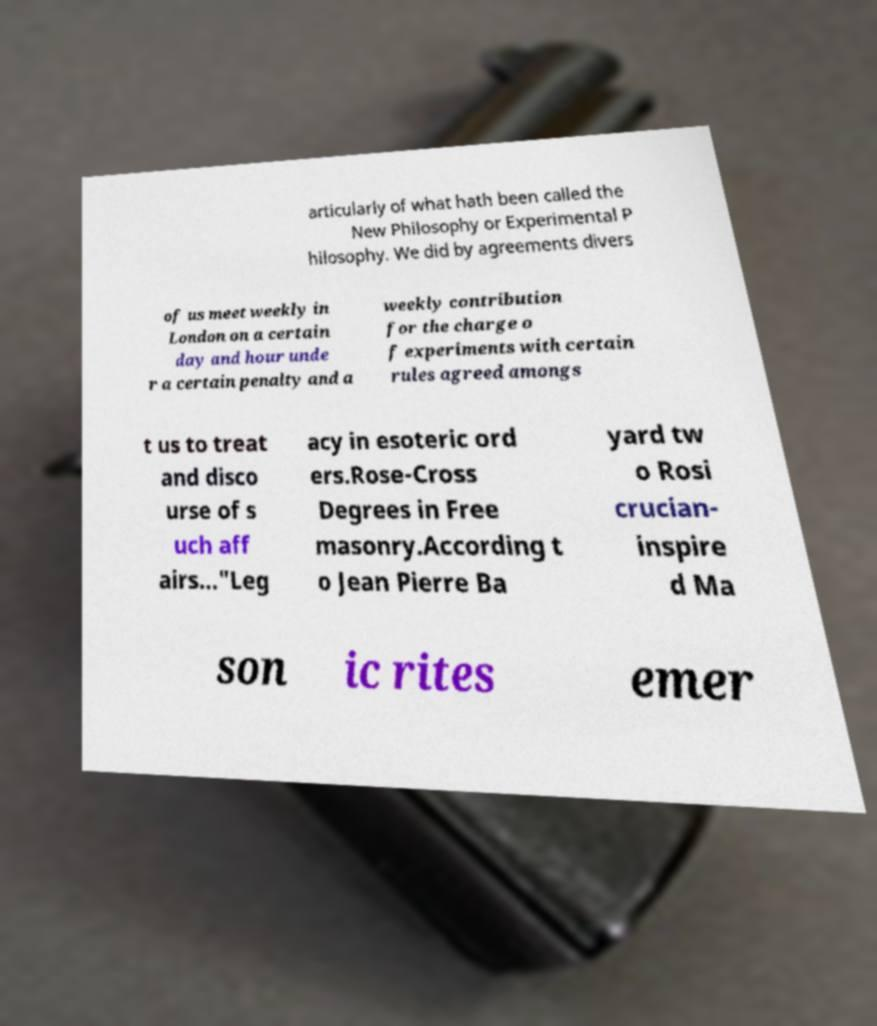Please read and relay the text visible in this image. What does it say? articularly of what hath been called the New Philosophy or Experimental P hilosophy. We did by agreements divers of us meet weekly in London on a certain day and hour unde r a certain penalty and a weekly contribution for the charge o f experiments with certain rules agreed amongs t us to treat and disco urse of s uch aff airs..."Leg acy in esoteric ord ers.Rose-Cross Degrees in Free masonry.According t o Jean Pierre Ba yard tw o Rosi crucian- inspire d Ma son ic rites emer 